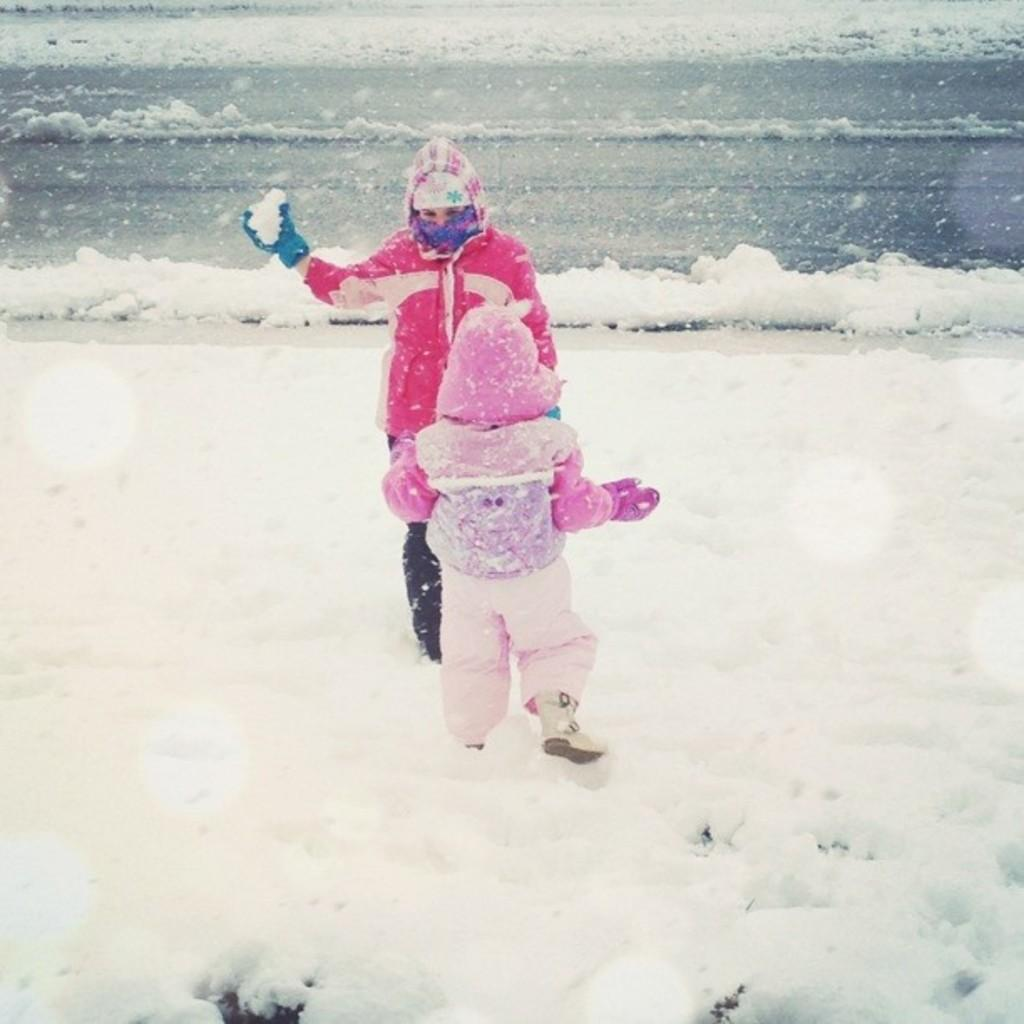How many people are in the image? There are two persons in the image. Where are the two persons located in the image? The two persons are standing in the center of the image. What are the two persons holding in the image? The two persons are holding snow in the image. What can be seen in the background of the image? There is snow visible in the background of the image. What type of twig can be seen in the image? There is no twig present in the image. How does the behavior of the sheep in the image affect the snow? There are no sheep present in the image, so their behavior cannot be observed. 